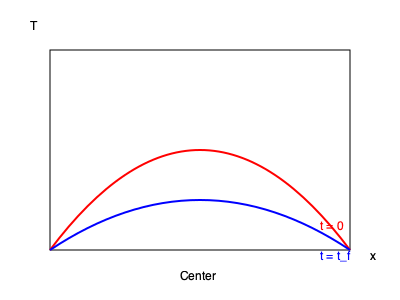In an exothermic sculptural reaction, the temperature distribution along the x-axis of a linear sculpture at time $t=0$ and $t=t_f$ is shown in the graph. Assuming the sculpture has a uniform thermal diffusivity $\alpha$ and the reaction occurs uniformly along its length, determine the relationship between the final time $t_f$ and $\alpha$ if the maximum temperature difference between the center and the ends decreases by a factor of $e$ (Euler's number). To solve this problem, we need to follow these steps:

1) The temperature distribution in a one-dimensional heat conduction problem is described by the heat equation:

   $$\frac{\partial T}{\partial t} = \alpha \frac{\partial^2 T}{\partial x^2}$$

2) The solution to this equation for an initial cosine temperature distribution is:

   $$T(x,t) = T_0 + A \cos(\frac{\pi x}{L}) e^{-\alpha (\frac{\pi}{L})^2 t}$$

   where $T_0$ is the ambient temperature, $A$ is the initial amplitude, and $L$ is the length of the sculpture.

3) The maximum temperature difference occurs at the center ($x=L/2$) and is given by:

   $$\Delta T_{max}(t) = A e^{-\alpha (\frac{\pi}{L})^2 t}$$

4) We're told that this maximum difference decreases by a factor of $e$ at time $t_f$. This means:

   $$\frac{\Delta T_{max}(t_f)}{\Delta T_{max}(0)} = \frac{1}{e}$$

5) Substituting the expression for $\Delta T_{max}(t)$:

   $$\frac{A e^{-\alpha (\frac{\pi}{L})^2 t_f}}{A} = \frac{1}{e}$$

6) Simplifying:

   $$e^{-\alpha (\frac{\pi}{L})^2 t_f} = \frac{1}{e}$$

7) Taking the natural logarithm of both sides:

   $$-\alpha (\frac{\pi}{L})^2 t_f = -1$$

8) Solving for $t_f$:

   $$t_f = \frac{L^2}{\alpha \pi^2}$$

This is the relationship between $t_f$ and $\alpha$.
Answer: $t_f = \frac{L^2}{\alpha \pi^2}$ 